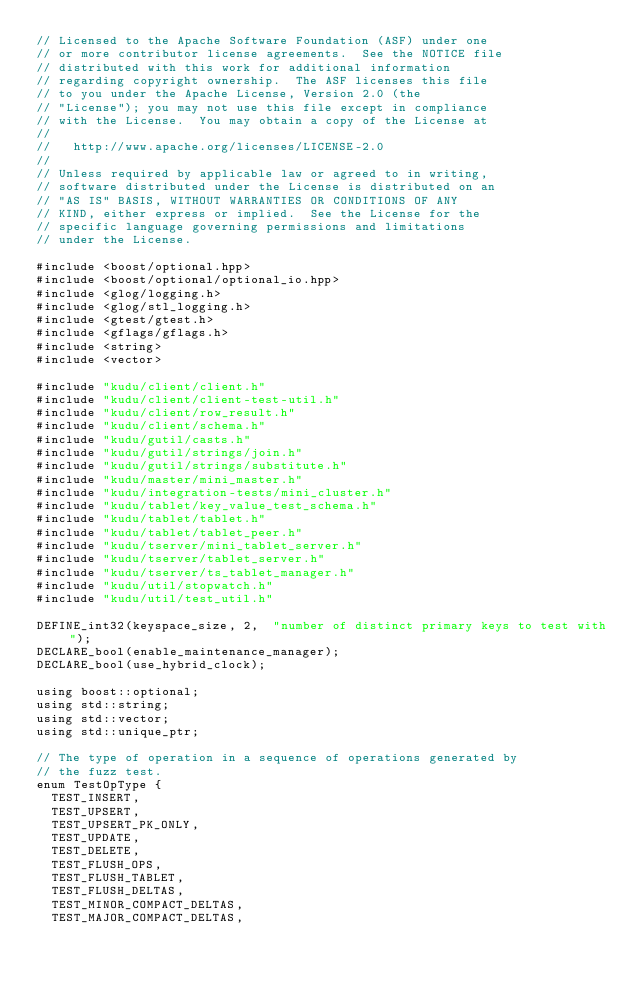<code> <loc_0><loc_0><loc_500><loc_500><_C++_>// Licensed to the Apache Software Foundation (ASF) under one
// or more contributor license agreements.  See the NOTICE file
// distributed with this work for additional information
// regarding copyright ownership.  The ASF licenses this file
// to you under the Apache License, Version 2.0 (the
// "License"); you may not use this file except in compliance
// with the License.  You may obtain a copy of the License at
//
//   http://www.apache.org/licenses/LICENSE-2.0
//
// Unless required by applicable law or agreed to in writing,
// software distributed under the License is distributed on an
// "AS IS" BASIS, WITHOUT WARRANTIES OR CONDITIONS OF ANY
// KIND, either express or implied.  See the License for the
// specific language governing permissions and limitations
// under the License.

#include <boost/optional.hpp>
#include <boost/optional/optional_io.hpp>
#include <glog/logging.h>
#include <glog/stl_logging.h>
#include <gtest/gtest.h>
#include <gflags/gflags.h>
#include <string>
#include <vector>

#include "kudu/client/client.h"
#include "kudu/client/client-test-util.h"
#include "kudu/client/row_result.h"
#include "kudu/client/schema.h"
#include "kudu/gutil/casts.h"
#include "kudu/gutil/strings/join.h"
#include "kudu/gutil/strings/substitute.h"
#include "kudu/master/mini_master.h"
#include "kudu/integration-tests/mini_cluster.h"
#include "kudu/tablet/key_value_test_schema.h"
#include "kudu/tablet/tablet.h"
#include "kudu/tablet/tablet_peer.h"
#include "kudu/tserver/mini_tablet_server.h"
#include "kudu/tserver/tablet_server.h"
#include "kudu/tserver/ts_tablet_manager.h"
#include "kudu/util/stopwatch.h"
#include "kudu/util/test_util.h"

DEFINE_int32(keyspace_size, 2,  "number of distinct primary keys to test with");
DECLARE_bool(enable_maintenance_manager);
DECLARE_bool(use_hybrid_clock);

using boost::optional;
using std::string;
using std::vector;
using std::unique_ptr;

// The type of operation in a sequence of operations generated by
// the fuzz test.
enum TestOpType {
  TEST_INSERT,
  TEST_UPSERT,
  TEST_UPSERT_PK_ONLY,
  TEST_UPDATE,
  TEST_DELETE,
  TEST_FLUSH_OPS,
  TEST_FLUSH_TABLET,
  TEST_FLUSH_DELTAS,
  TEST_MINOR_COMPACT_DELTAS,
  TEST_MAJOR_COMPACT_DELTAS,</code> 